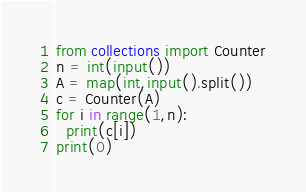<code> <loc_0><loc_0><loc_500><loc_500><_Python_>from collections import Counter
n = int(input())
A = map(int,input().split())
c = Counter(A)
for i in range(1,n):
  print(c[i])
print(0)  </code> 